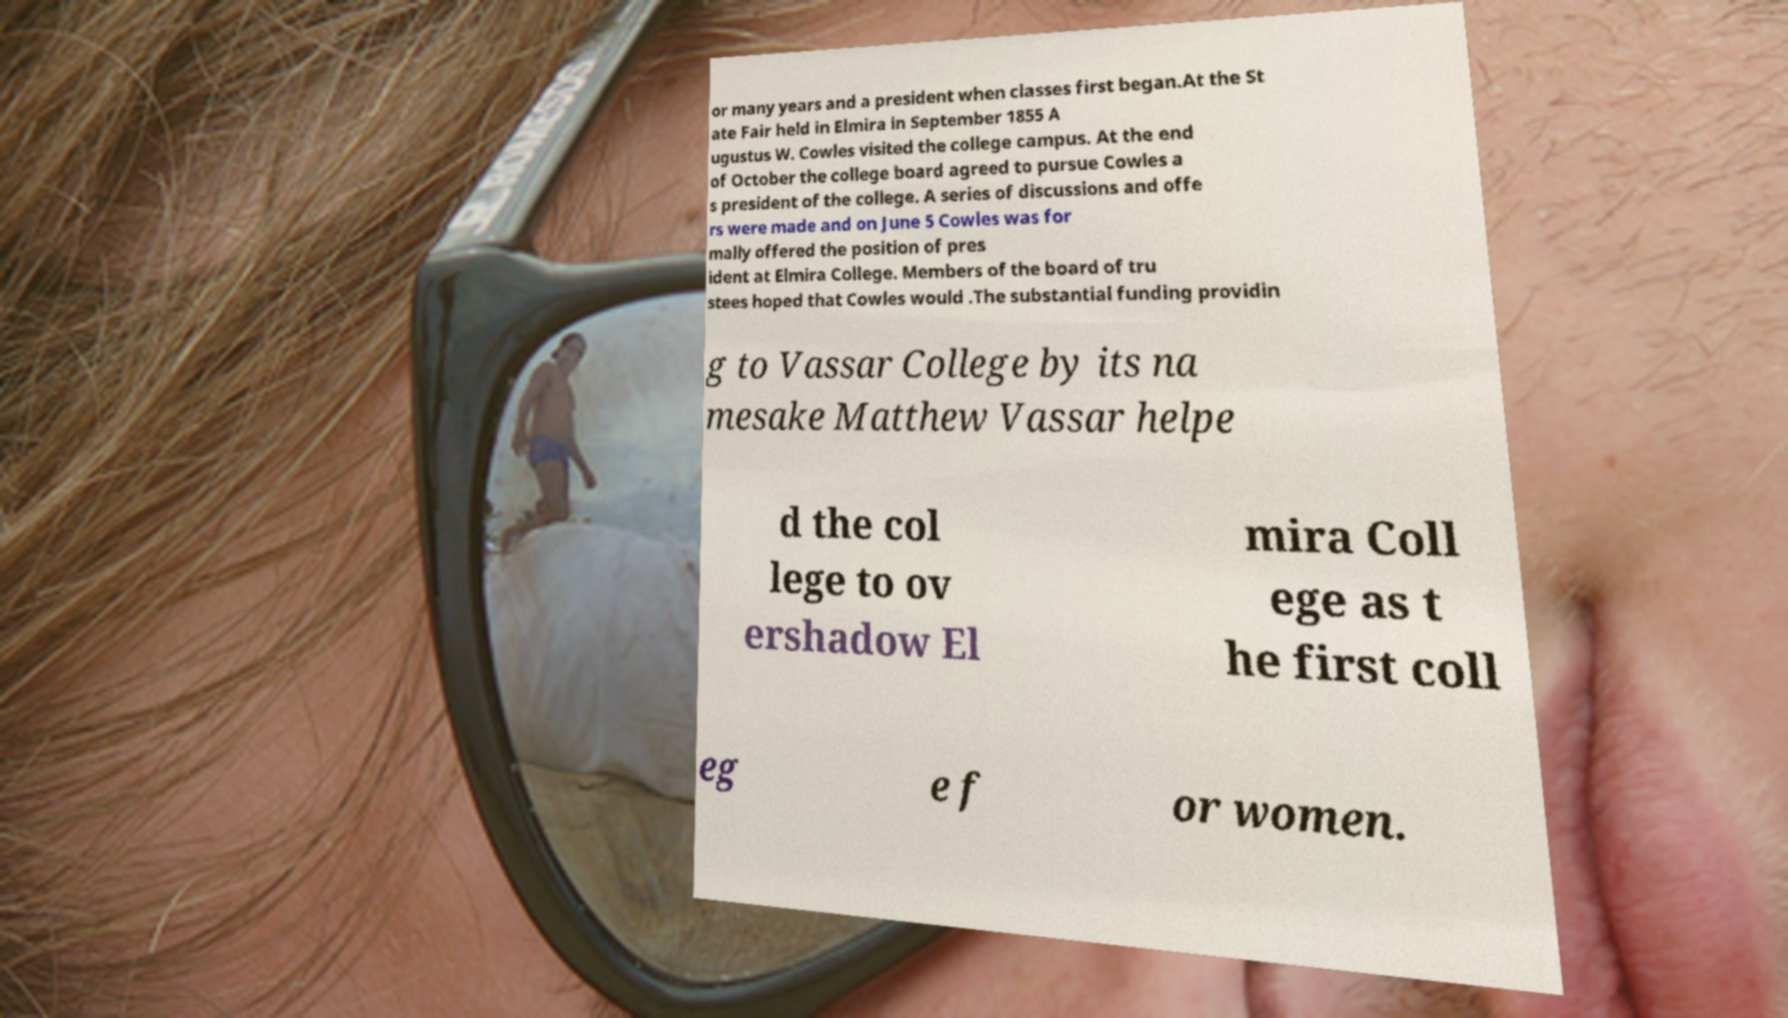I need the written content from this picture converted into text. Can you do that? or many years and a president when classes first began.At the St ate Fair held in Elmira in September 1855 A ugustus W. Cowles visited the college campus. At the end of October the college board agreed to pursue Cowles a s president of the college. A series of discussions and offe rs were made and on June 5 Cowles was for mally offered the position of pres ident at Elmira College. Members of the board of tru stees hoped that Cowles would .The substantial funding providin g to Vassar College by its na mesake Matthew Vassar helpe d the col lege to ov ershadow El mira Coll ege as t he first coll eg e f or women. 